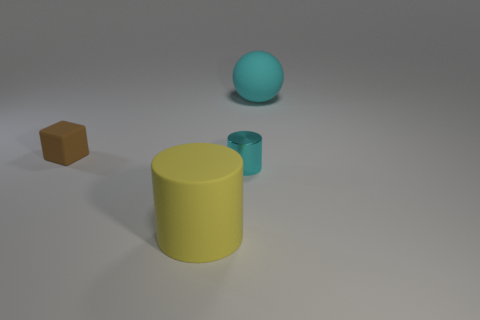Add 2 small cyan objects. How many objects exist? 6 Subtract all balls. How many objects are left? 3 Add 1 large matte things. How many large matte things exist? 3 Subtract 1 cyan cylinders. How many objects are left? 3 Subtract all small red spheres. Subtract all large yellow things. How many objects are left? 3 Add 2 large cyan things. How many large cyan things are left? 3 